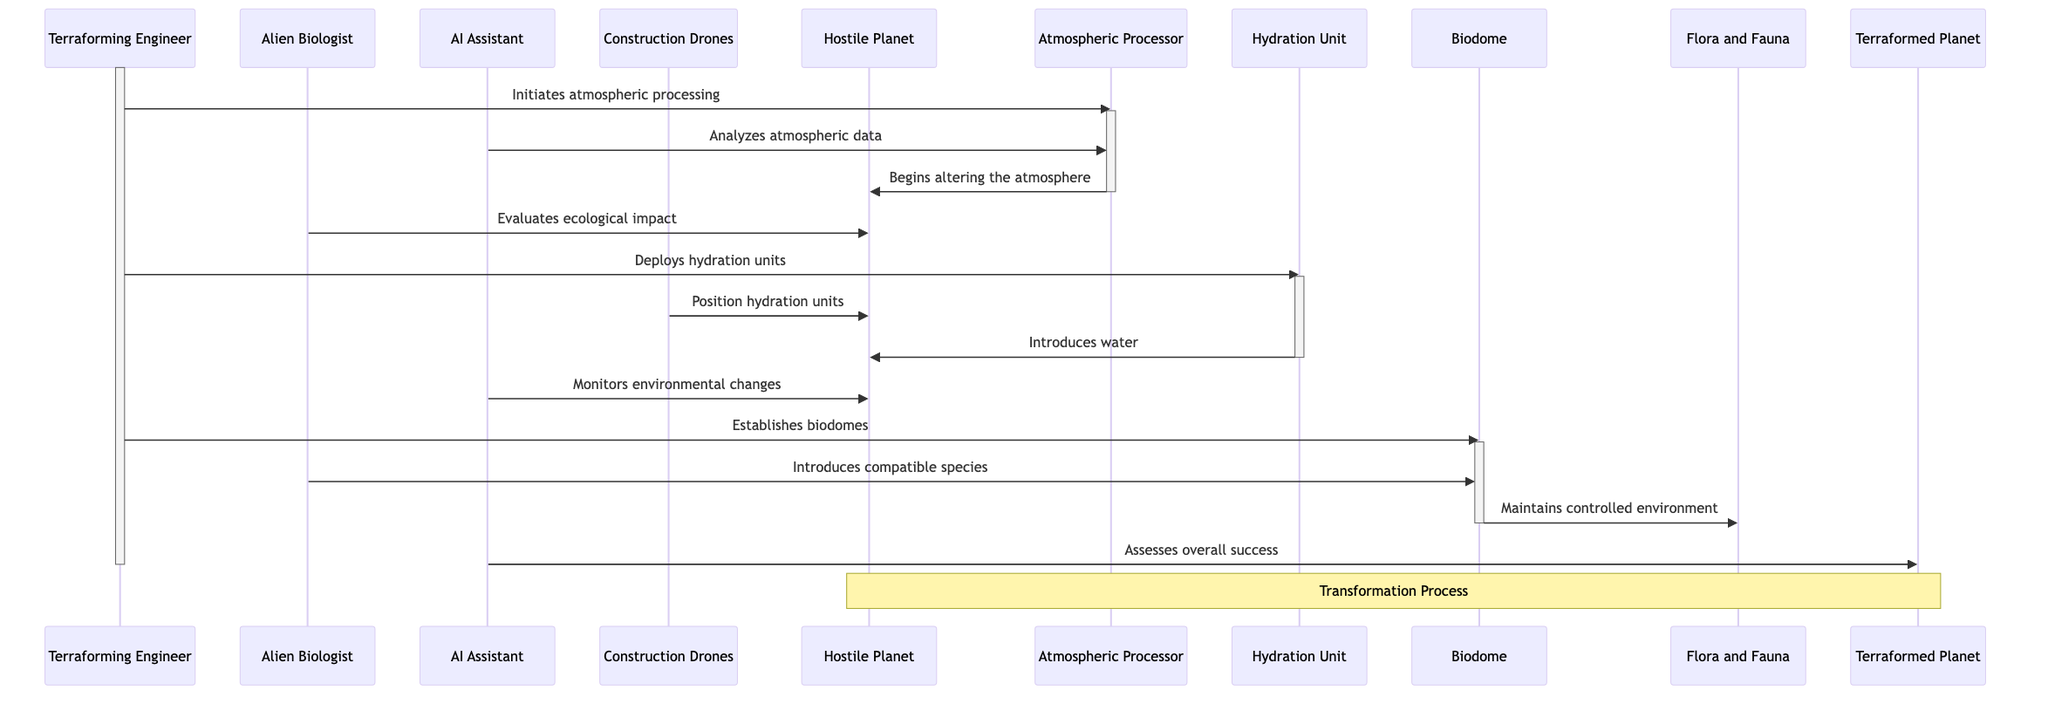What is the role of the Terraforming Engineer? The Terraforming Engineer is a human expert managing the terraforming project, responsible for initiating and overseeing various tasks throughout the process.
Answer: Human expert managing the terraforming project How many main actors are involved in the terraforming process? The diagram includes four main actors: Terraforming Engineer, Alien Biologist, AI Assistant, and Construction Drones, which are all essential in different roles during the terraforming process.
Answer: 4 What technology is used to alter the atmosphere? The Atmospheric Processor is specifically designed to modify the planet's atmosphere, which is a crucial step in making the planet hospitable.
Answer: Atmospheric Processor Who monitors environmental changes after water introduction? After the introduction of water, the AI Assistant is responsible for monitoring the environmental changes to assess the progress of the terraforming efforts.
Answer: AI Assistant What is the final action taken in the terraforming process? The final action is for the AI Assistant to assess the overall success of the transformation, evaluating if the target planet has become hospitable.
Answer: Assesses overall success Which actor is responsible for positioning the hydration units? The Construction Drones are tasked with positioning the hydration units on the hostile planet, playing a key role in implementing the terraforming modifications.
Answer: Construction Drones What action does the Atmospheric Processor take first? The Atmospheric Processor begins altering the atmosphere of the hostile planet immediately after the Terraforming Engineer initiates the atmospheric processing.
Answer: Begins altering the atmosphere What happens after the Alien Biologist evaluates ecological impact? After evaluation, the Terraforming Engineer proceeded to deploy hydration units to further promote the transformation of the planet into a hospitable environment.
Answer: Deploys hydration units How does the Biodome contribute to the transformation process? The Biodome maintains a controlled environment for flora and fauna, which is crucial in supporting the ecological diversity needed for a hospitable habitat.
Answer: Maintains controlled environment 